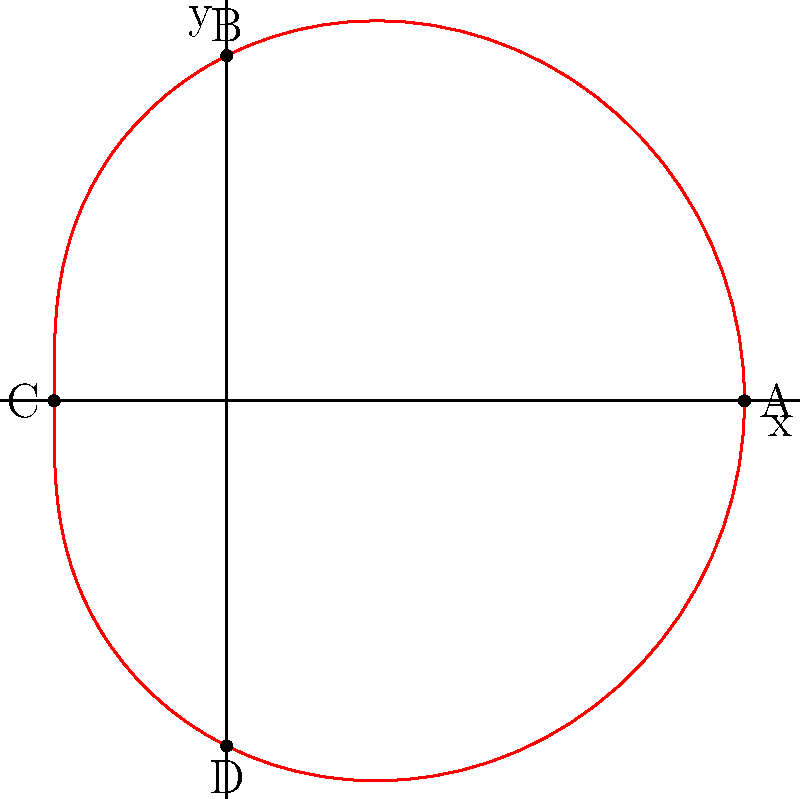In a scene, four characters (A, B, C, and D) are positioned based on their emotional distance from the protagonist at the center. Their positions are plotted on a polar graph where the radius represents emotional closeness (smaller radius means closer relationship) and the angle represents the type of relationship. Given the polar equation $r = 2 + \cos(\theta)$, which character has the closest emotional connection to the protagonist? To determine which character has the closest emotional connection to the protagonist, we need to find the minimum value of the radius function $r = 2 + \cos(\theta)$. 

Step 1: Analyze the function
The radius is determined by $r = 2 + \cos(\theta)$. The constant term 2 shifts the entire graph outward, while $\cos(\theta)$ causes the radius to oscillate between 1 and 3.

Step 2: Find the minimum value
The minimum value of $\cos(\theta)$ is -1, which occurs when $\theta = \pi$ (or 180°).
At this point, $r_{min} = 2 + (-1) = 1$

Step 3: Identify the character positions
A: $\theta = 0°$ (right)
B: $\theta = 90°$ (top)
C: $\theta = 180°$ (left)
D: $\theta = 270°$ (bottom)

Step 4: Evaluate the radius for each character
A: $r_A = 2 + \cos(0°) = 2 + 1 = 3$
B: $r_B = 2 + \cos(90°) = 2 + 0 = 2$
D: $r_D = 2 + \cos(270°) = 2 + 0 = 2$
C: $r_C = 2 + \cos(180°) = 2 + (-1) = 1$

Step 5: Compare the radii
Character C has the smallest radius (1), which means they are positioned closest to the center.

Therefore, Character C has the closest emotional connection to the protagonist.
Answer: Character C 